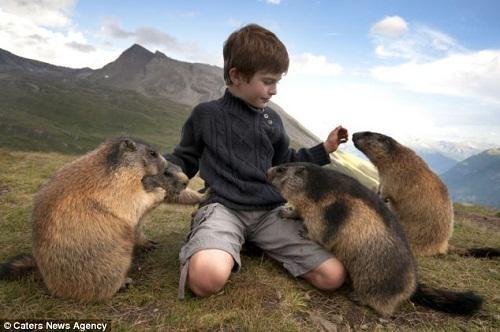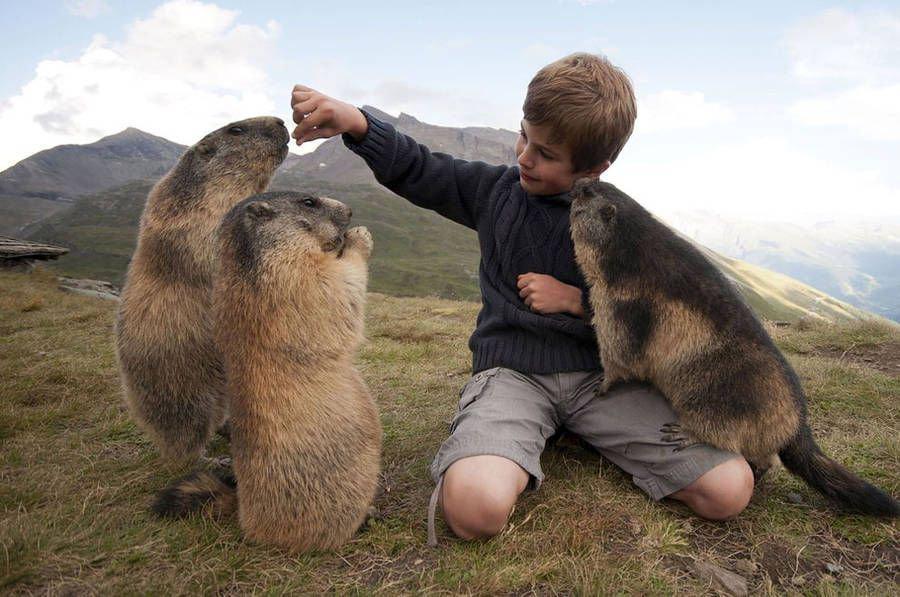The first image is the image on the left, the second image is the image on the right. Analyze the images presented: Is the assertion "A boy is kneeling on the ground as he plays with at least 3 groundhogs." valid? Answer yes or no. Yes. The first image is the image on the left, the second image is the image on the right. For the images displayed, is the sentence "In one image there is a lone marmot looking towards the camera." factually correct? Answer yes or no. No. 